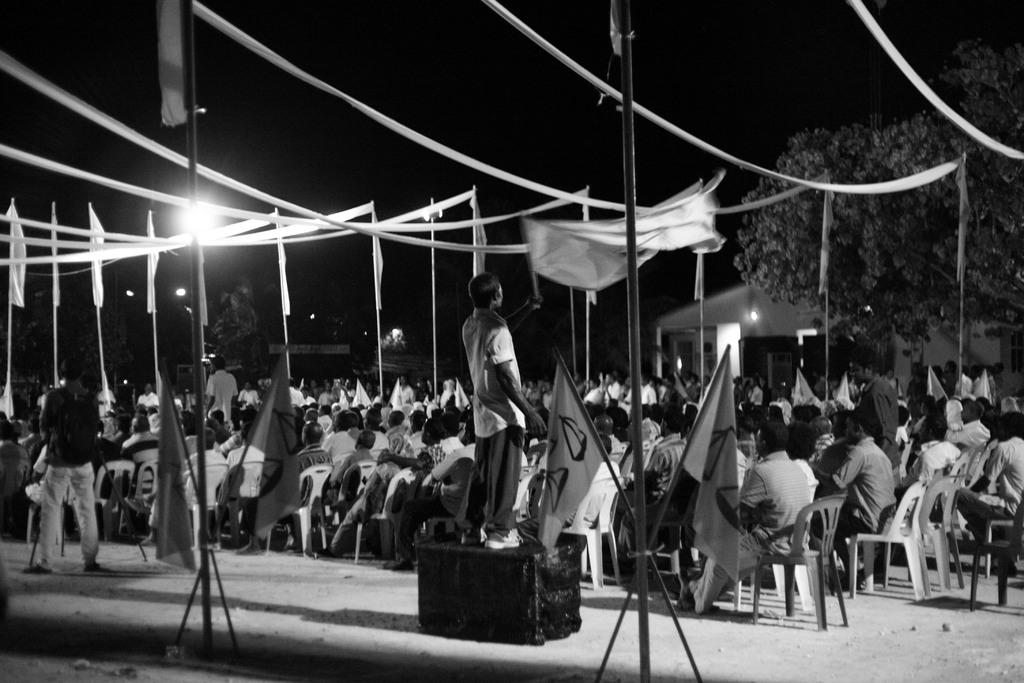What can be seen in the image that represents a symbol or country? There are flags in the image. What are the people in the image doing? Some people are sitting on chairs, and some are standing. What can be seen in the background of the image? There are lights and trees in the background of the image. What type of agreement did the dad sign in the image? There is no dad or agreement present in the image. How many additions were made to the image during the photoshoot? The image provided does not mention any photoshoot or additions; it only shows the flags, people, chairs, lights, and trees. 